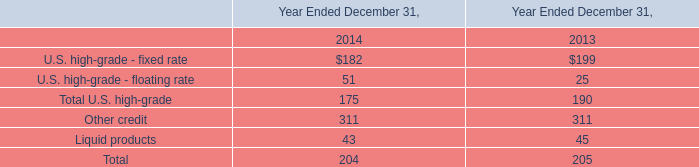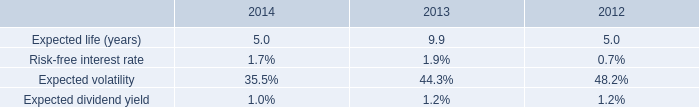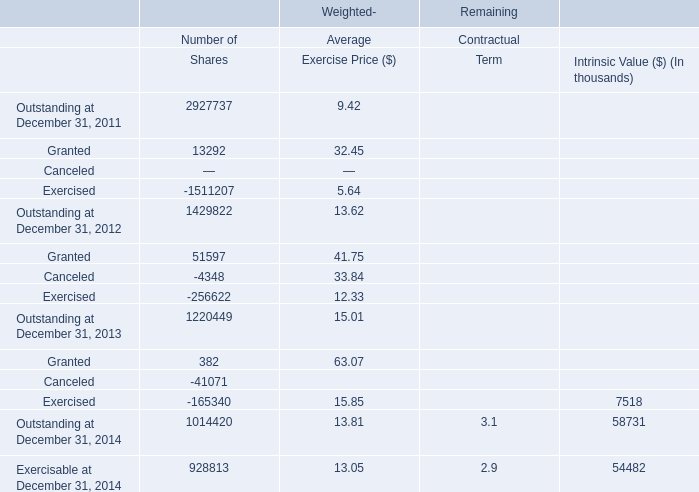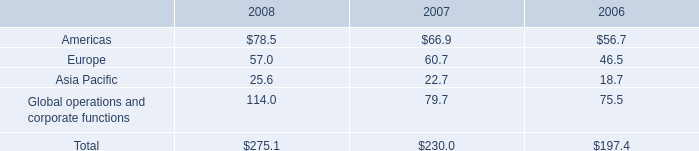Which element has the second largest number in 2011 for Shares? 
Answer: Granted. 